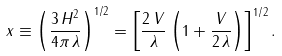<formula> <loc_0><loc_0><loc_500><loc_500>x \equiv \left ( \frac { 3 \, H ^ { 2 } } { 4 \pi \, \lambda } \right ) ^ { 1 / 2 } = \left [ \frac { 2 \, V } { \lambda } \left ( 1 + \frac { V } { 2 \, \lambda } \right ) \right ] ^ { 1 / 2 } .</formula> 